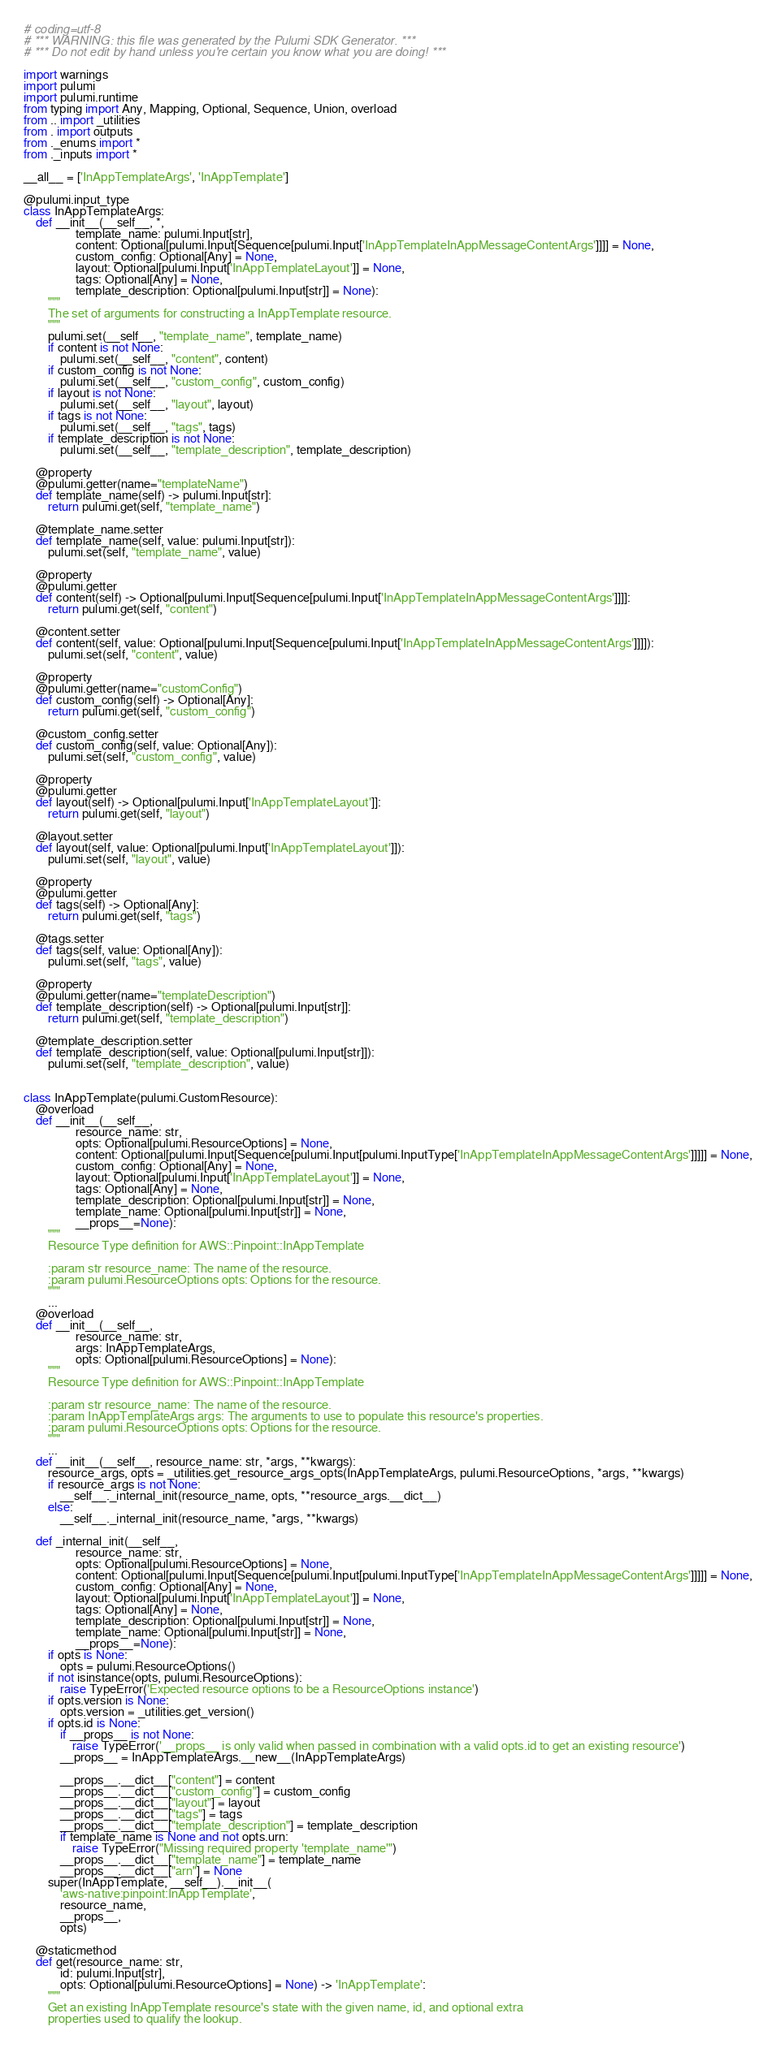<code> <loc_0><loc_0><loc_500><loc_500><_Python_># coding=utf-8
# *** WARNING: this file was generated by the Pulumi SDK Generator. ***
# *** Do not edit by hand unless you're certain you know what you are doing! ***

import warnings
import pulumi
import pulumi.runtime
from typing import Any, Mapping, Optional, Sequence, Union, overload
from .. import _utilities
from . import outputs
from ._enums import *
from ._inputs import *

__all__ = ['InAppTemplateArgs', 'InAppTemplate']

@pulumi.input_type
class InAppTemplateArgs:
    def __init__(__self__, *,
                 template_name: pulumi.Input[str],
                 content: Optional[pulumi.Input[Sequence[pulumi.Input['InAppTemplateInAppMessageContentArgs']]]] = None,
                 custom_config: Optional[Any] = None,
                 layout: Optional[pulumi.Input['InAppTemplateLayout']] = None,
                 tags: Optional[Any] = None,
                 template_description: Optional[pulumi.Input[str]] = None):
        """
        The set of arguments for constructing a InAppTemplate resource.
        """
        pulumi.set(__self__, "template_name", template_name)
        if content is not None:
            pulumi.set(__self__, "content", content)
        if custom_config is not None:
            pulumi.set(__self__, "custom_config", custom_config)
        if layout is not None:
            pulumi.set(__self__, "layout", layout)
        if tags is not None:
            pulumi.set(__self__, "tags", tags)
        if template_description is not None:
            pulumi.set(__self__, "template_description", template_description)

    @property
    @pulumi.getter(name="templateName")
    def template_name(self) -> pulumi.Input[str]:
        return pulumi.get(self, "template_name")

    @template_name.setter
    def template_name(self, value: pulumi.Input[str]):
        pulumi.set(self, "template_name", value)

    @property
    @pulumi.getter
    def content(self) -> Optional[pulumi.Input[Sequence[pulumi.Input['InAppTemplateInAppMessageContentArgs']]]]:
        return pulumi.get(self, "content")

    @content.setter
    def content(self, value: Optional[pulumi.Input[Sequence[pulumi.Input['InAppTemplateInAppMessageContentArgs']]]]):
        pulumi.set(self, "content", value)

    @property
    @pulumi.getter(name="customConfig")
    def custom_config(self) -> Optional[Any]:
        return pulumi.get(self, "custom_config")

    @custom_config.setter
    def custom_config(self, value: Optional[Any]):
        pulumi.set(self, "custom_config", value)

    @property
    @pulumi.getter
    def layout(self) -> Optional[pulumi.Input['InAppTemplateLayout']]:
        return pulumi.get(self, "layout")

    @layout.setter
    def layout(self, value: Optional[pulumi.Input['InAppTemplateLayout']]):
        pulumi.set(self, "layout", value)

    @property
    @pulumi.getter
    def tags(self) -> Optional[Any]:
        return pulumi.get(self, "tags")

    @tags.setter
    def tags(self, value: Optional[Any]):
        pulumi.set(self, "tags", value)

    @property
    @pulumi.getter(name="templateDescription")
    def template_description(self) -> Optional[pulumi.Input[str]]:
        return pulumi.get(self, "template_description")

    @template_description.setter
    def template_description(self, value: Optional[pulumi.Input[str]]):
        pulumi.set(self, "template_description", value)


class InAppTemplate(pulumi.CustomResource):
    @overload
    def __init__(__self__,
                 resource_name: str,
                 opts: Optional[pulumi.ResourceOptions] = None,
                 content: Optional[pulumi.Input[Sequence[pulumi.Input[pulumi.InputType['InAppTemplateInAppMessageContentArgs']]]]] = None,
                 custom_config: Optional[Any] = None,
                 layout: Optional[pulumi.Input['InAppTemplateLayout']] = None,
                 tags: Optional[Any] = None,
                 template_description: Optional[pulumi.Input[str]] = None,
                 template_name: Optional[pulumi.Input[str]] = None,
                 __props__=None):
        """
        Resource Type definition for AWS::Pinpoint::InAppTemplate

        :param str resource_name: The name of the resource.
        :param pulumi.ResourceOptions opts: Options for the resource.
        """
        ...
    @overload
    def __init__(__self__,
                 resource_name: str,
                 args: InAppTemplateArgs,
                 opts: Optional[pulumi.ResourceOptions] = None):
        """
        Resource Type definition for AWS::Pinpoint::InAppTemplate

        :param str resource_name: The name of the resource.
        :param InAppTemplateArgs args: The arguments to use to populate this resource's properties.
        :param pulumi.ResourceOptions opts: Options for the resource.
        """
        ...
    def __init__(__self__, resource_name: str, *args, **kwargs):
        resource_args, opts = _utilities.get_resource_args_opts(InAppTemplateArgs, pulumi.ResourceOptions, *args, **kwargs)
        if resource_args is not None:
            __self__._internal_init(resource_name, opts, **resource_args.__dict__)
        else:
            __self__._internal_init(resource_name, *args, **kwargs)

    def _internal_init(__self__,
                 resource_name: str,
                 opts: Optional[pulumi.ResourceOptions] = None,
                 content: Optional[pulumi.Input[Sequence[pulumi.Input[pulumi.InputType['InAppTemplateInAppMessageContentArgs']]]]] = None,
                 custom_config: Optional[Any] = None,
                 layout: Optional[pulumi.Input['InAppTemplateLayout']] = None,
                 tags: Optional[Any] = None,
                 template_description: Optional[pulumi.Input[str]] = None,
                 template_name: Optional[pulumi.Input[str]] = None,
                 __props__=None):
        if opts is None:
            opts = pulumi.ResourceOptions()
        if not isinstance(opts, pulumi.ResourceOptions):
            raise TypeError('Expected resource options to be a ResourceOptions instance')
        if opts.version is None:
            opts.version = _utilities.get_version()
        if opts.id is None:
            if __props__ is not None:
                raise TypeError('__props__ is only valid when passed in combination with a valid opts.id to get an existing resource')
            __props__ = InAppTemplateArgs.__new__(InAppTemplateArgs)

            __props__.__dict__["content"] = content
            __props__.__dict__["custom_config"] = custom_config
            __props__.__dict__["layout"] = layout
            __props__.__dict__["tags"] = tags
            __props__.__dict__["template_description"] = template_description
            if template_name is None and not opts.urn:
                raise TypeError("Missing required property 'template_name'")
            __props__.__dict__["template_name"] = template_name
            __props__.__dict__["arn"] = None
        super(InAppTemplate, __self__).__init__(
            'aws-native:pinpoint:InAppTemplate',
            resource_name,
            __props__,
            opts)

    @staticmethod
    def get(resource_name: str,
            id: pulumi.Input[str],
            opts: Optional[pulumi.ResourceOptions] = None) -> 'InAppTemplate':
        """
        Get an existing InAppTemplate resource's state with the given name, id, and optional extra
        properties used to qualify the lookup.
</code> 